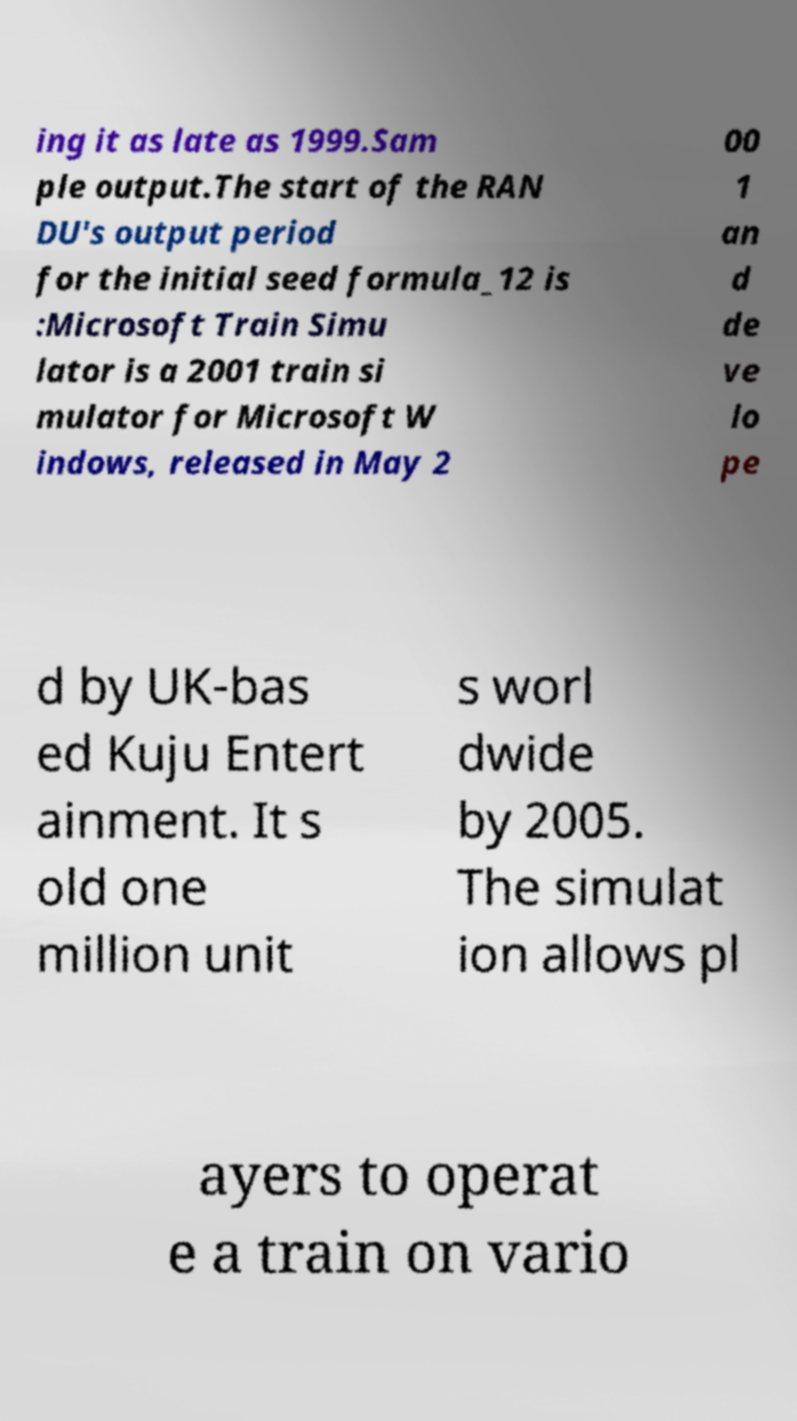Please identify and transcribe the text found in this image. ing it as late as 1999.Sam ple output.The start of the RAN DU's output period for the initial seed formula_12 is :Microsoft Train Simu lator is a 2001 train si mulator for Microsoft W indows, released in May 2 00 1 an d de ve lo pe d by UK-bas ed Kuju Entert ainment. It s old one million unit s worl dwide by 2005. The simulat ion allows pl ayers to operat e a train on vario 